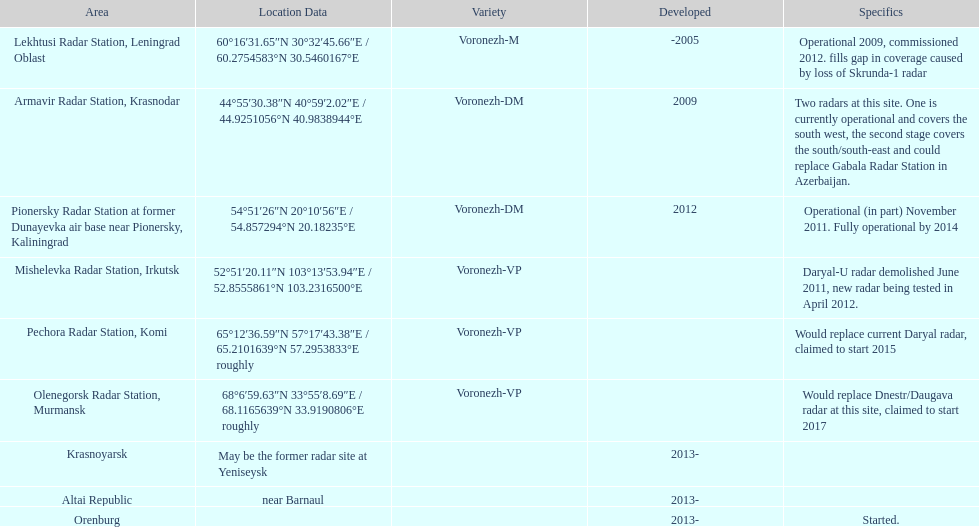How many voronezh radars were built before 2010? 2. 